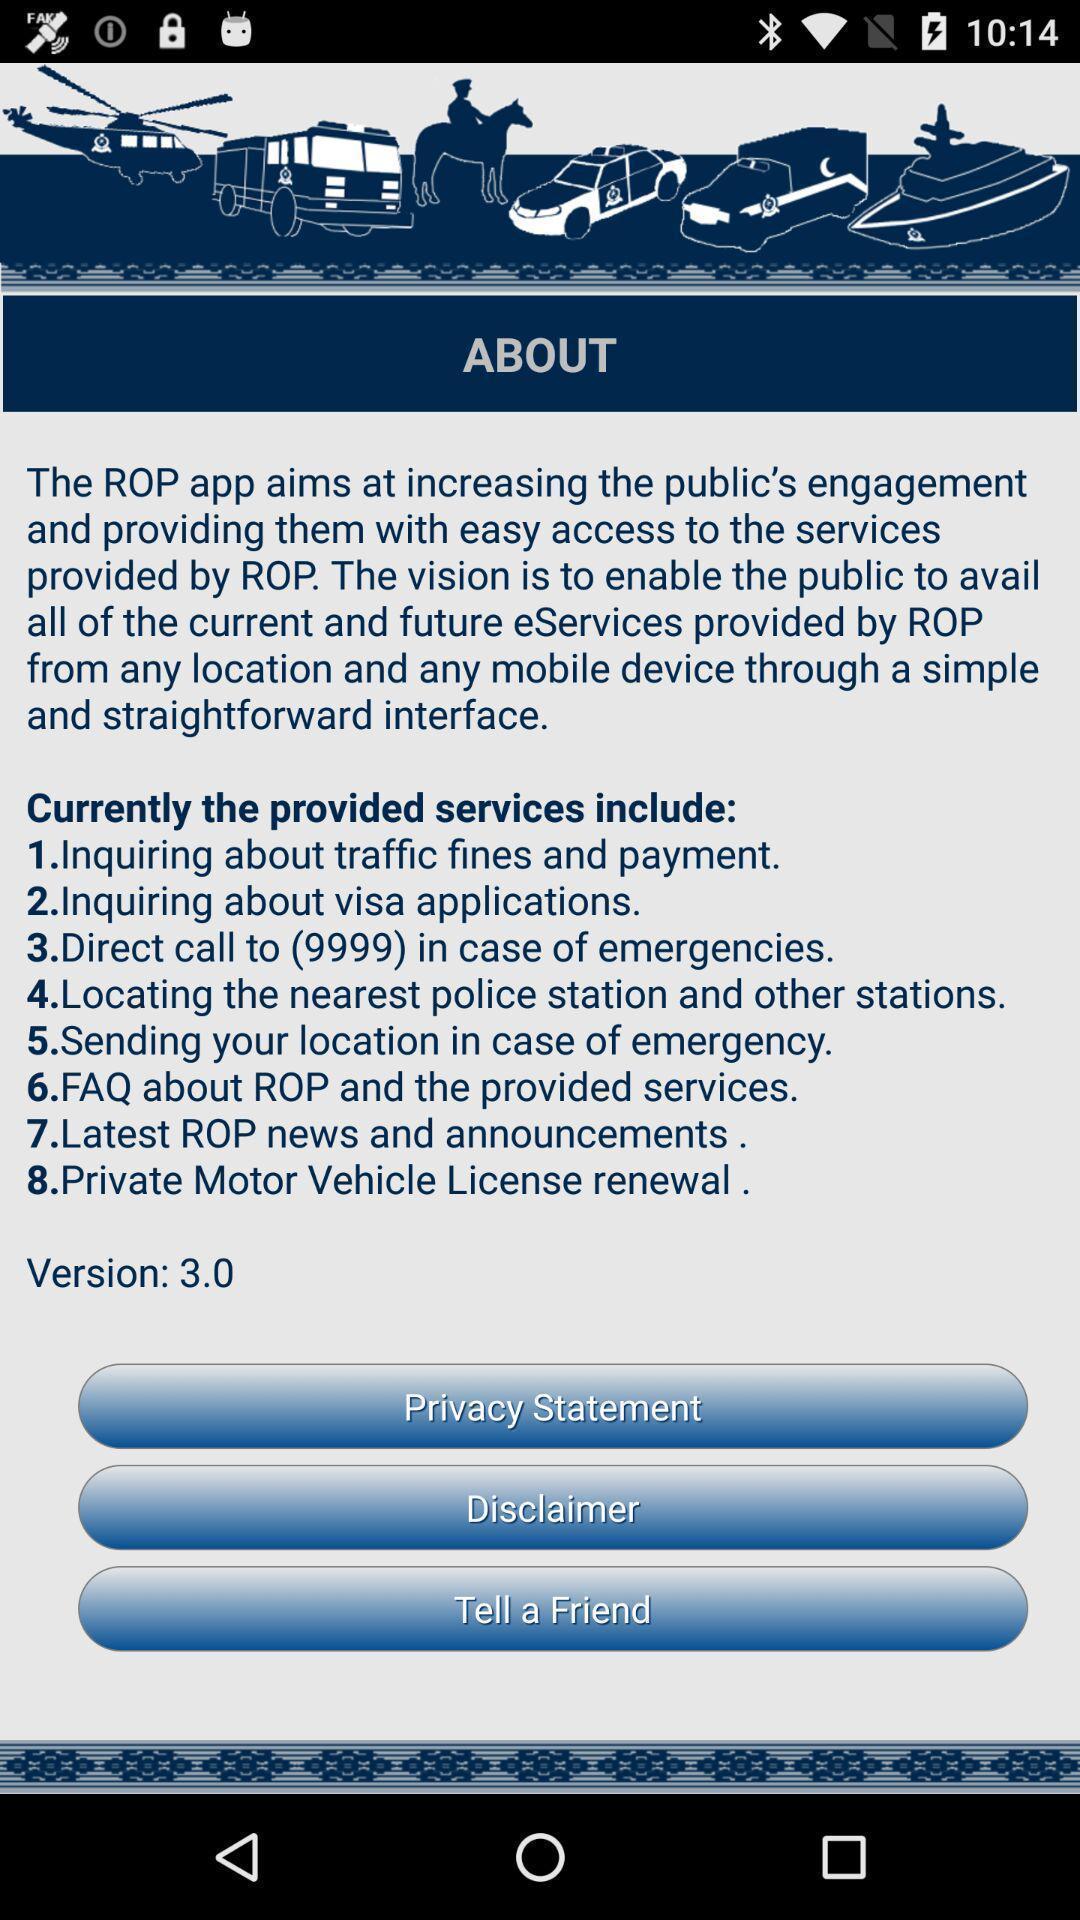Please provide a description for this image. Page of description of an travelling app. 